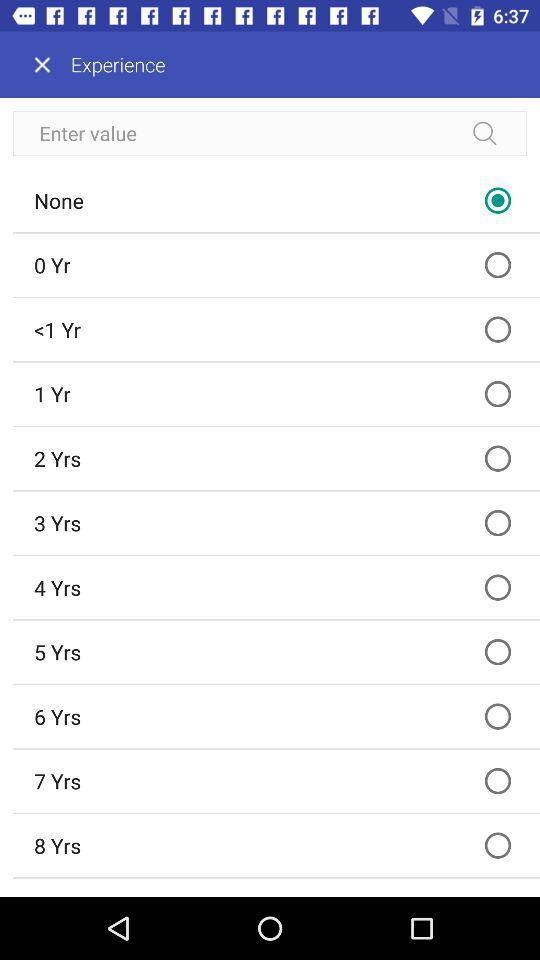What option was selected? The selected option was "None". 